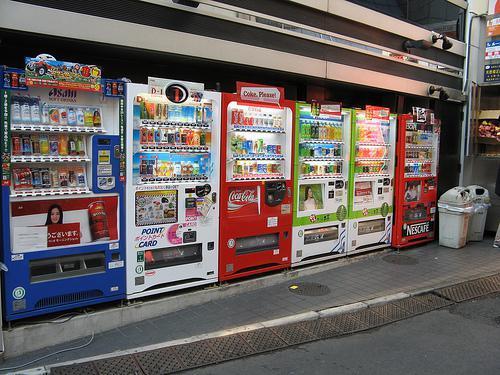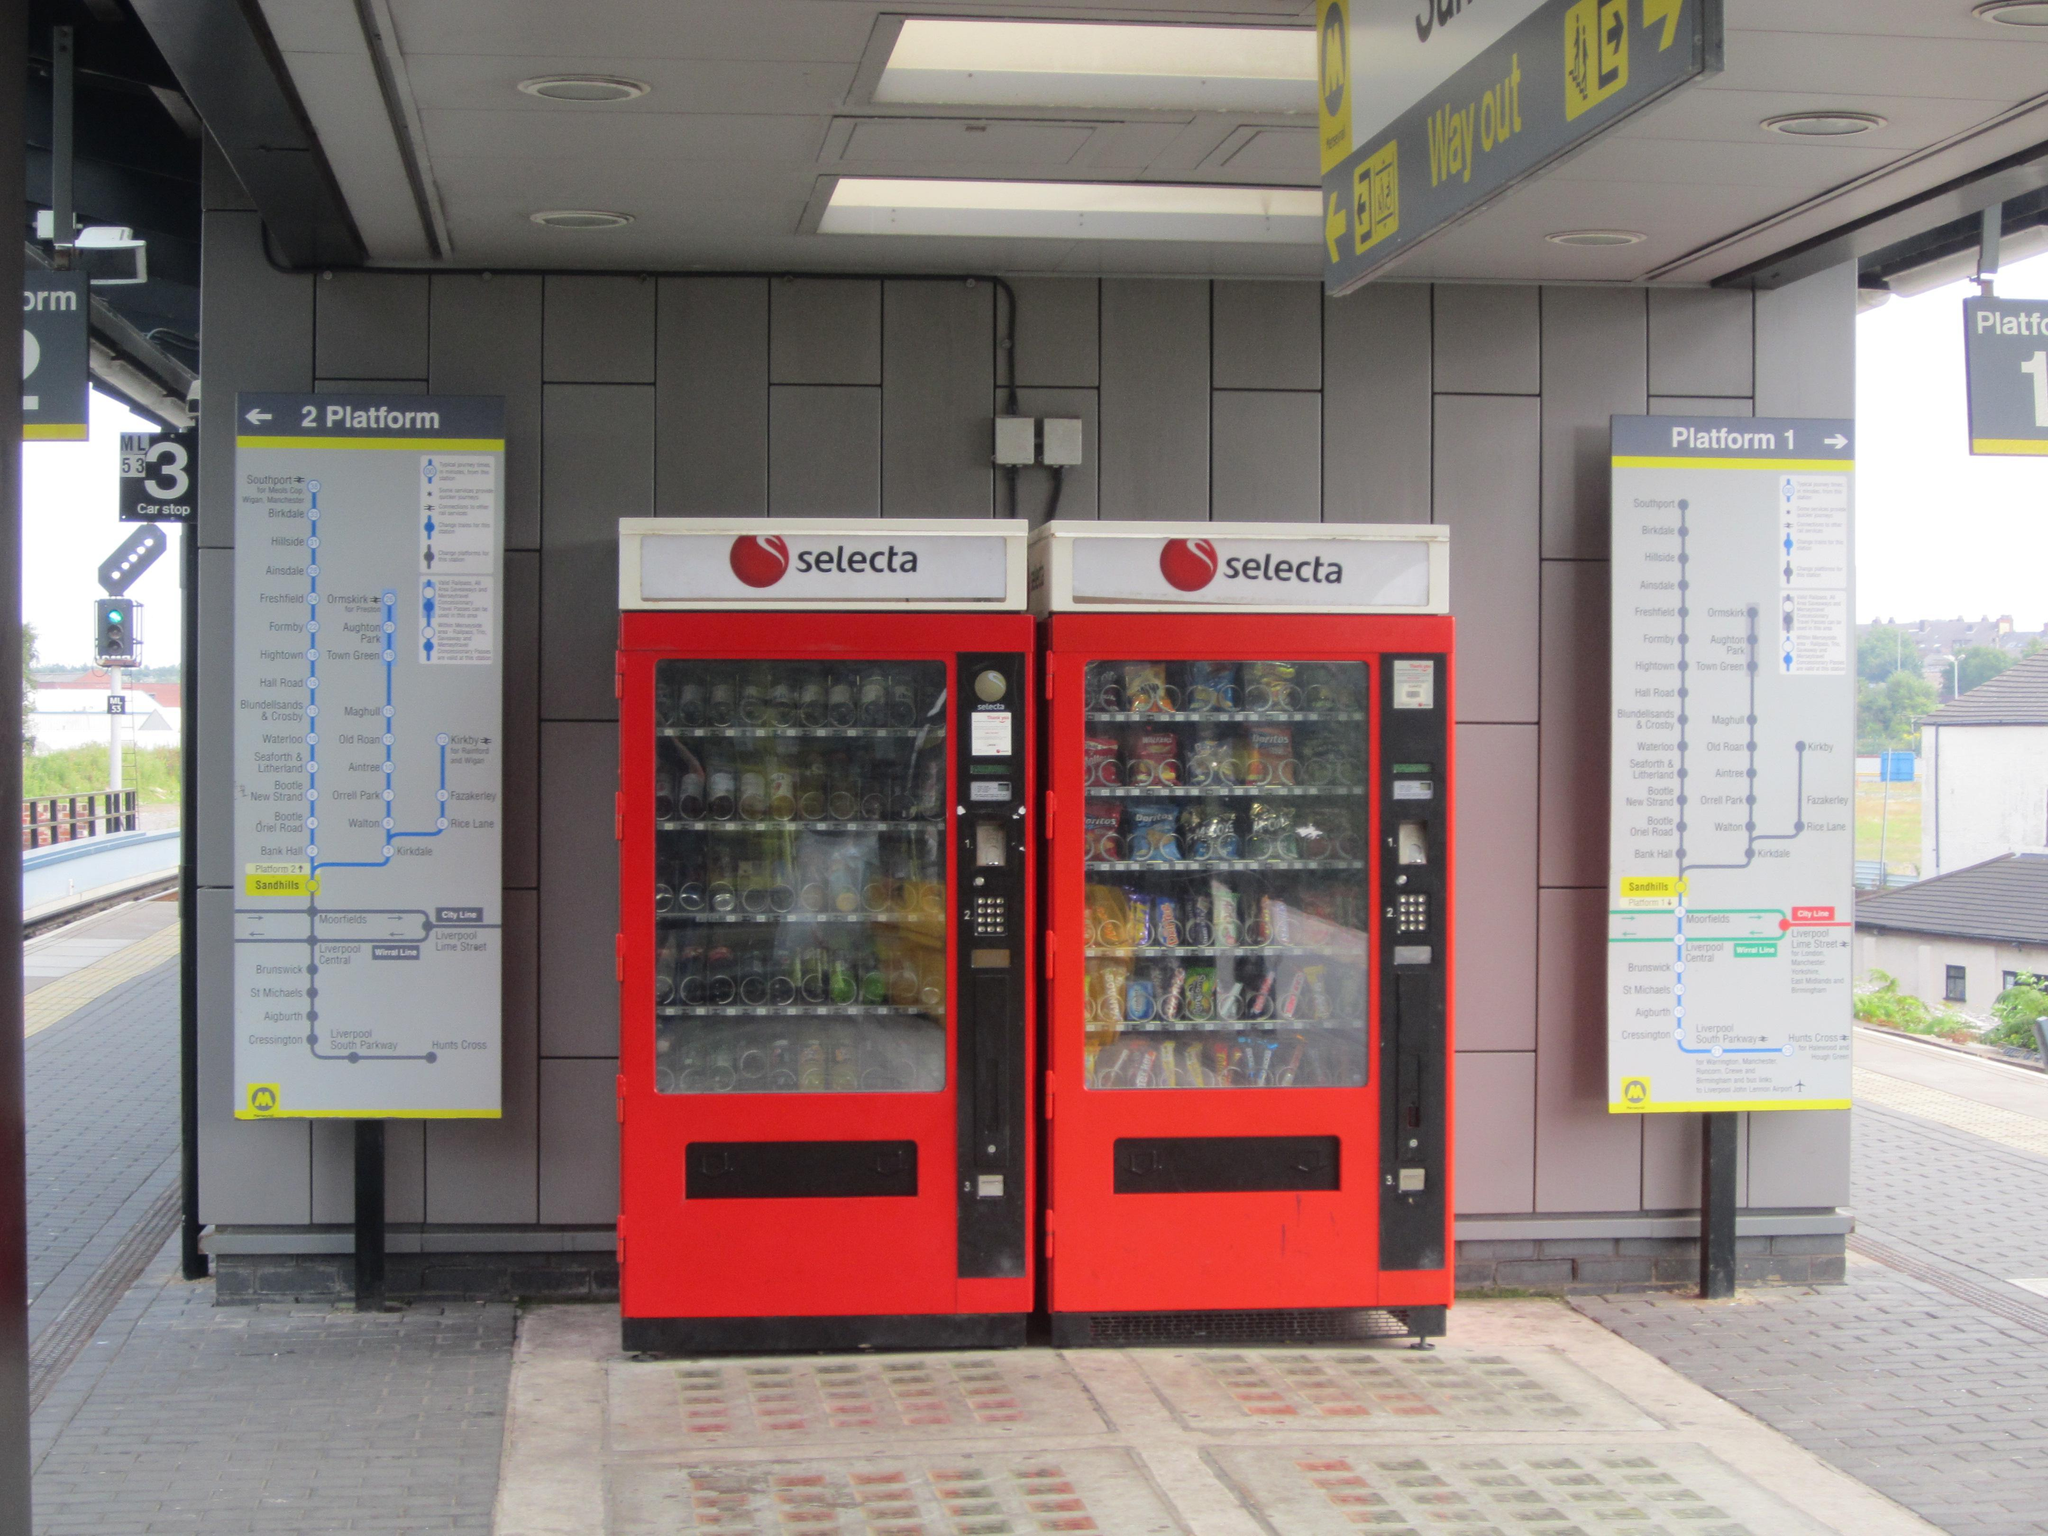The first image is the image on the left, the second image is the image on the right. Evaluate the accuracy of this statement regarding the images: "In the left image, there are at least four different vending machines.". Is it true? Answer yes or no. Yes. The first image is the image on the left, the second image is the image on the right. Considering the images on both sides, is "At least one of the images contains only a single vending machine." valid? Answer yes or no. No. 